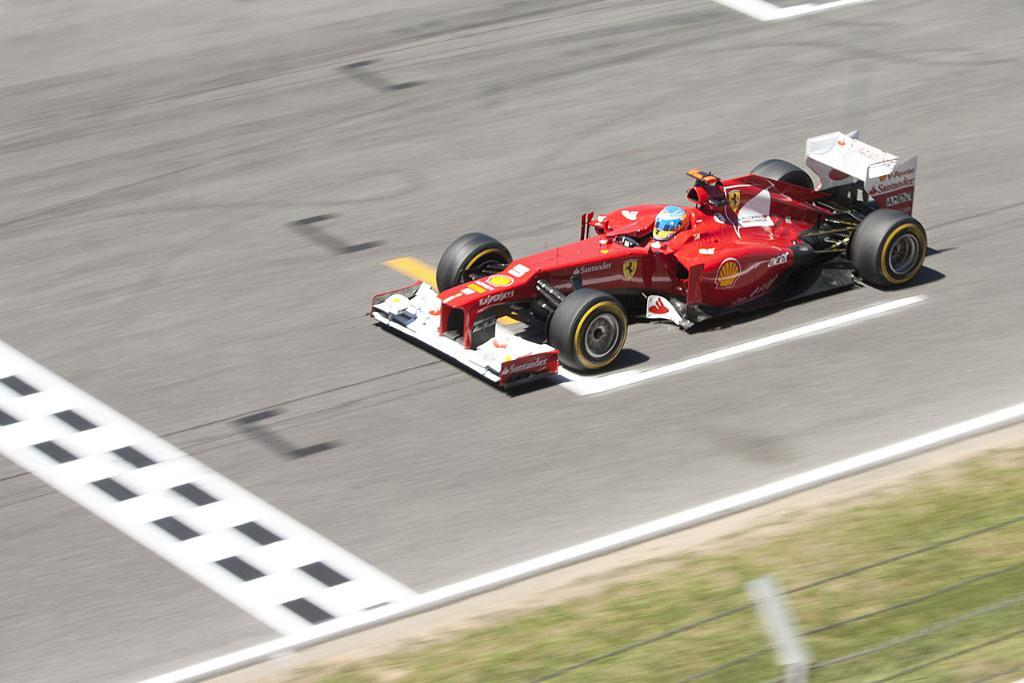What can be seen running through the image? There are wires in the image. What type of surface is visible on the ground in the image? There is grass on the ground in the image. What type of protective gear is visible in the image? There is a helmet visible in the image. What type of vehicle is present on the road in the image? There is a car on the road in the image. What type of potato can be seen growing in the grass in the image? There are no potatoes visible in the image; it features grass on the ground. What type of ray is flying over the car in the image? There are no rays visible in the image; it features a car on the road. 